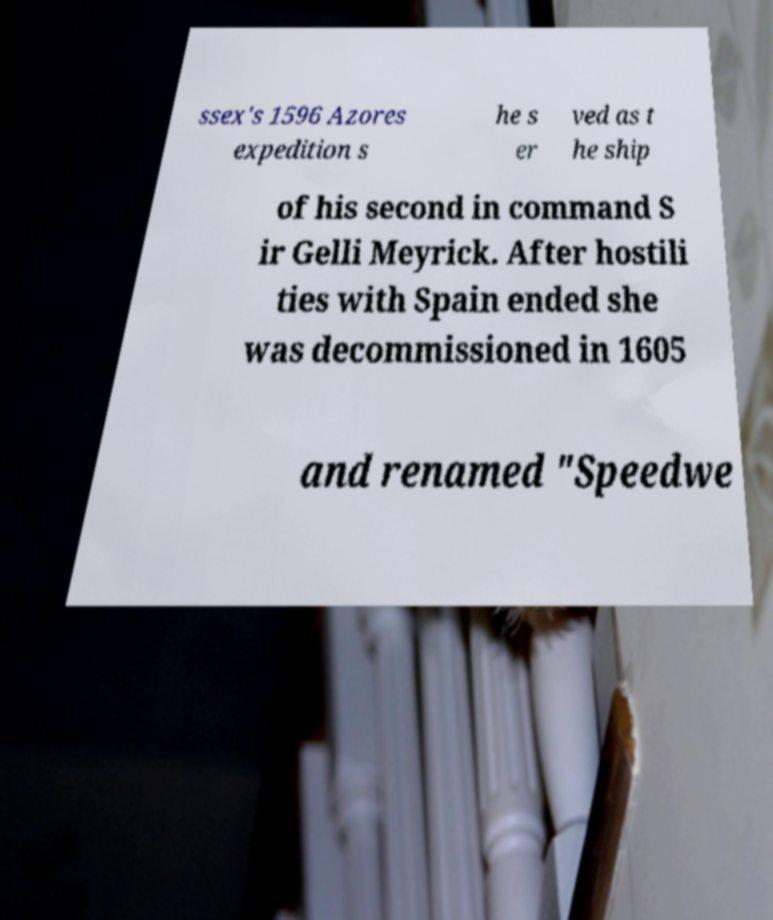Please identify and transcribe the text found in this image. ssex's 1596 Azores expedition s he s er ved as t he ship of his second in command S ir Gelli Meyrick. After hostili ties with Spain ended she was decommissioned in 1605 and renamed "Speedwe 